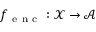Convert formula to latex. <formula><loc_0><loc_0><loc_500><loc_500>f _ { e n c } \colon \mathcal { X } \mathcal { A }</formula> 